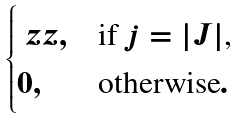Convert formula to latex. <formula><loc_0><loc_0><loc_500><loc_500>\begin{cases} \ z z , & \text {if $j=|J|$,} \\ 0 , & \text {otherwise} . \end{cases}</formula> 